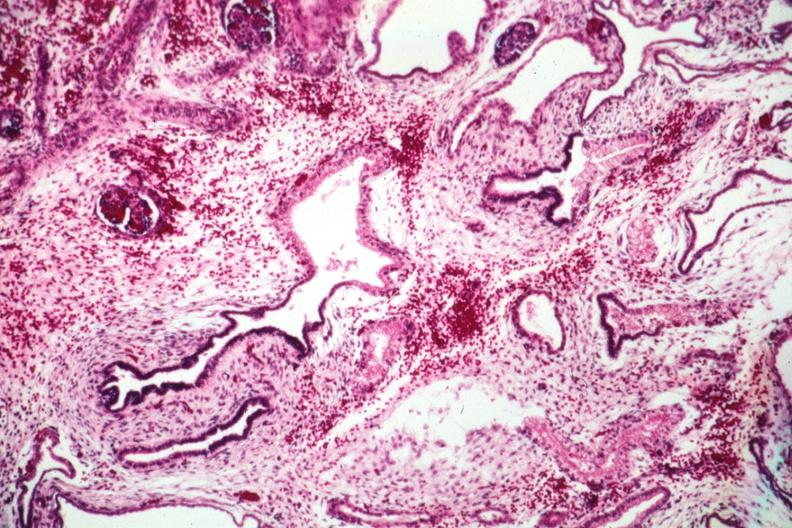s polycystic disease infant present?
Answer the question using a single word or phrase. Yes 